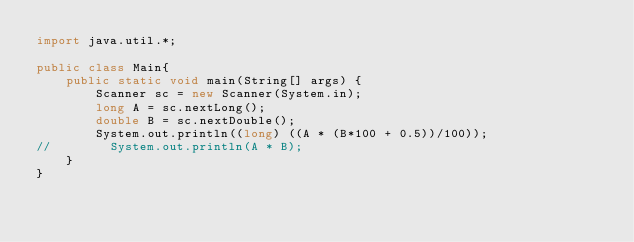Convert code to text. <code><loc_0><loc_0><loc_500><loc_500><_Java_>import java.util.*;

public class Main{
    public static void main(String[] args) {
        Scanner sc = new Scanner(System.in);
        long A = sc.nextLong();
        double B = sc.nextDouble();
        System.out.println((long) ((A * (B*100 + 0.5))/100));
//        System.out.println(A * B);
    }
}</code> 